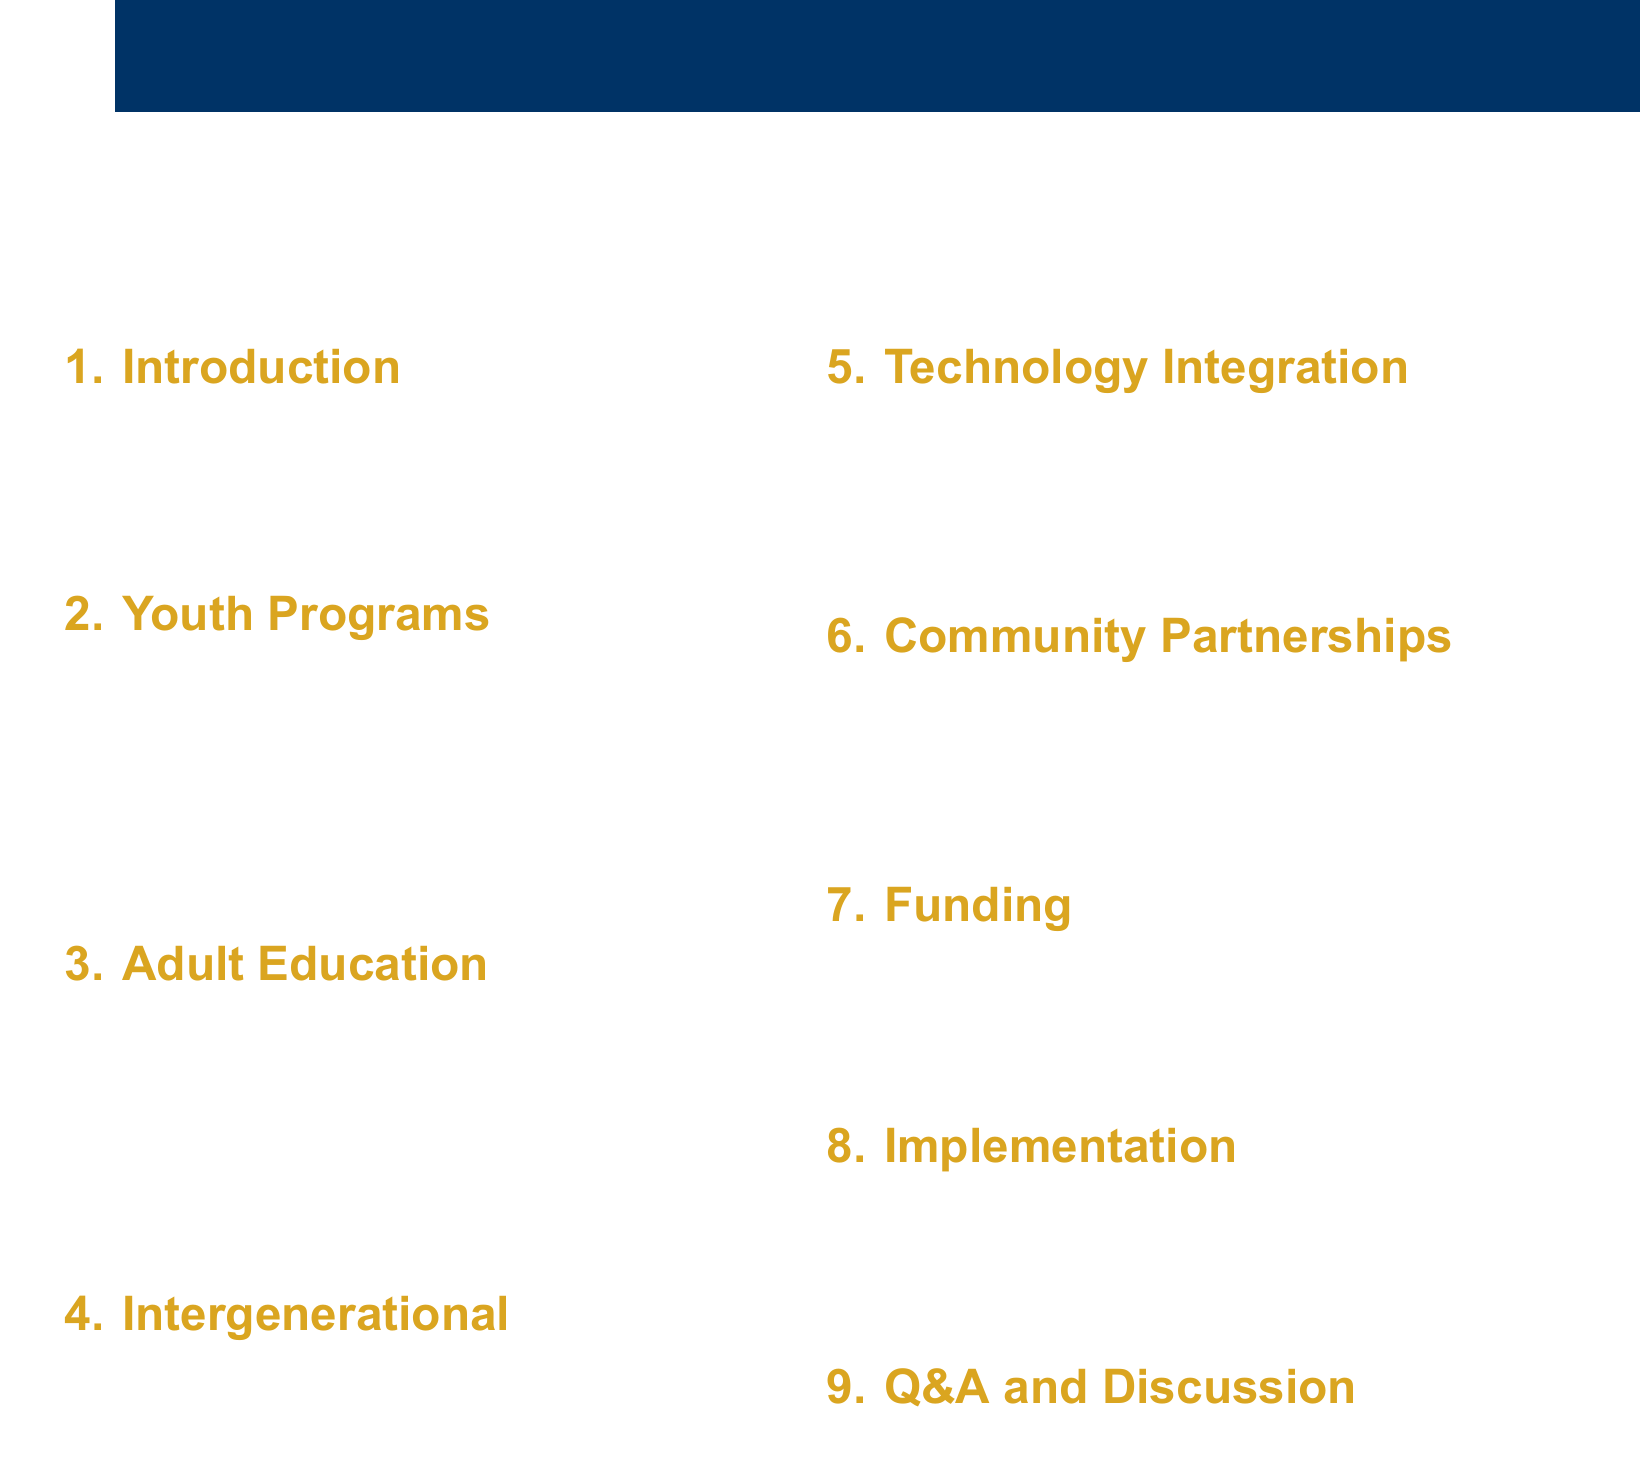What is the title of the first agenda item? The first agenda item is the introductory overview, which is titled "Introduction of new educational programs."
Answer: Introduction of new educational programs Who is the speaker for the funding discussion? The funding discussion includes a speaker who provides insights on budget requirements.
Answer: David Levy How many youth-focused programs are listed? The document outlines specific youth-focused programs that are presented as subtopics under a main agenda item.
Answer: Three What type of partnership is proposed for Holocaust education? The document mentions a specific type of collaboration for educational purposes.
Answer: Joint program with the Museum of Jewish Heritage What is one of the adult education initiatives mentioned? The agenda includes several initiatives aimed at adult education, and one example can be found in the listed subtopics.
Answer: Lunch and Learn series Which program focuses on virtual reality? The document proposes a specific technology-based initiative that involves VR experiences.
Answer: Virtual Reality Torah Tour What is the purpose of the Oral History Project? The description of the project explains its aim to connect members of the community for a certain activity.
Answer: Document personal stories of Jewish experiences How often is the Lunch and Learn series scheduled? The agenda provides information about the frequency of the educational sessions for adults.
Answer: Weekly sessions 